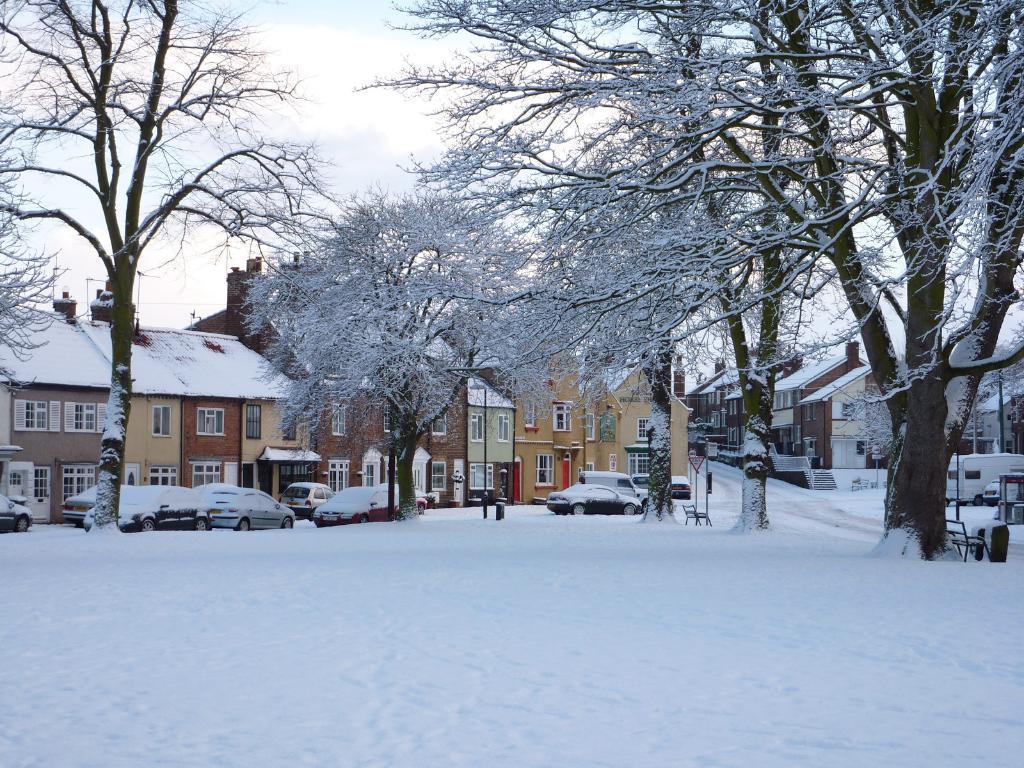Please provide a concise description of this image. In this image we can see snow, cars, poles, trees, bench, buildings, stairs and sky. 